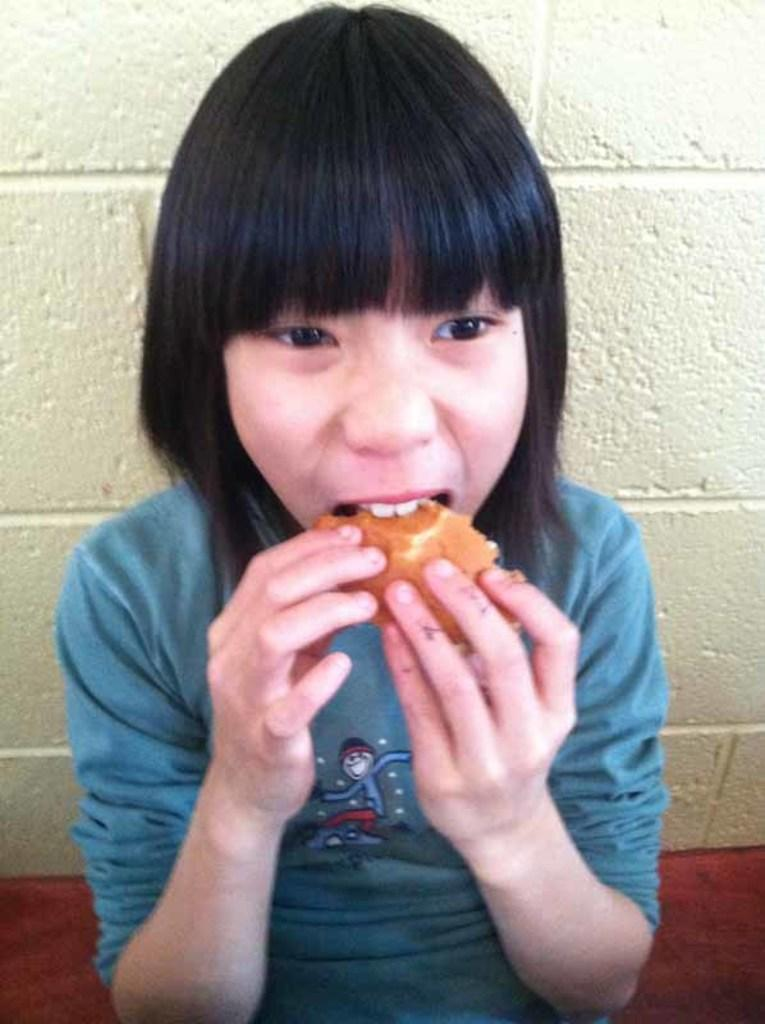Who is the main subject in the picture? There is a woman in the picture. What is the woman doing in the image? The woman is eating bread. Where is the woman sitting in the image? The woman is sitting on a bench. What can be seen in the background of the picture? There is a wall visible in the picture. How many hydrants are visible in the image? There are no hydrants present in the image. What is the temperature in degrees Celsius in the image? The image does not provide information about the temperature, so we cannot determine the temperature in degrees Celsius. 